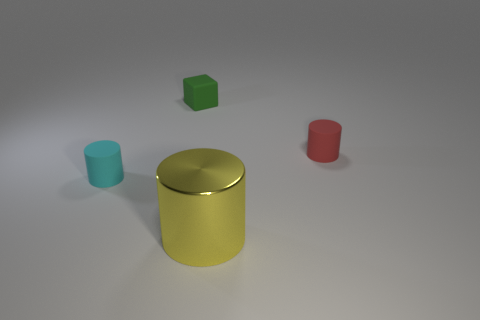Is there a yellow sphere made of the same material as the tiny cyan object?
Your answer should be very brief. No. Do the cylinder on the left side of the big yellow metal cylinder and the thing that is behind the red matte object have the same material?
Offer a terse response. Yes. Are there an equal number of large yellow metal cylinders that are to the right of the red rubber cylinder and cyan rubber cylinders that are in front of the cyan object?
Your response must be concise. Yes. There is another cylinder that is the same size as the red cylinder; what color is it?
Give a very brief answer. Cyan. Are there any other large shiny cylinders that have the same color as the shiny cylinder?
Your answer should be very brief. No. How many things are either tiny matte cylinders that are on the left side of the yellow metallic cylinder or purple cylinders?
Your answer should be very brief. 1. What number of other things are the same size as the cyan rubber cylinder?
Give a very brief answer. 2. There is a tiny cylinder in front of the rubber cylinder behind the tiny object to the left of the small green matte block; what is it made of?
Keep it short and to the point. Rubber. What number of balls are either big gray matte things or cyan matte objects?
Make the answer very short. 0. Is there any other thing that is the same shape as the metal thing?
Provide a short and direct response. Yes. 